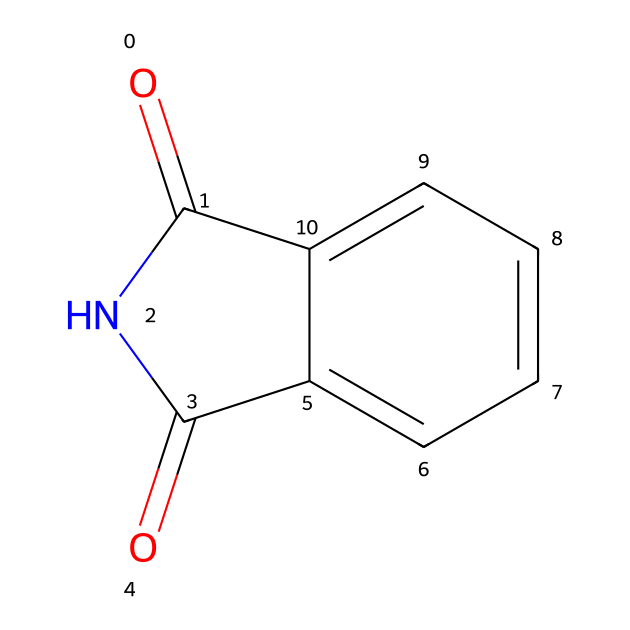What is the molecular formula of phthalimide? By analyzing the structure provided, we identify the types and quantities of each atom in phthalimide. The chemical structure contains 8 carbon atoms, 5 hydrogen atoms, 2 nitrogen atoms, and 2 oxygen atoms. Constructing the molecular formula from this information gives us C8H5N2O2.
Answer: C8H5N2O2 How many rings are present in the structure of phthalimide? Observing the structure, we see that phthalimide contains one cyclic structure, indicated by the presence of a ring formed by the bonding between nitrogen and carbon atoms.
Answer: 1 What functional groups are present in phthalimide? The structure reveals that phthalimide contains an imide group, characterized by the nitrogen atoms bonded to carbonyl groups (C=O). The presence of two carbonyls adjacent to the nitrogen highlights this functional group's significance.
Answer: imide What is the hybridization of the nitrogen atom in phthalimide? Looking at the structure, we note that the nitrogen atoms are bonded to carbonyl groups and carbon atoms, sharing electron pairs. This bonding suggests a trigonal planar arrangement, leading us to conclude that the nitrogen atoms are sp2 hybridized.
Answer: sp2 What type of reaction may phthalimide undergo in pesticide synthesis? In the context of pesticide synthesis, phthalimide is likely to participate in a nucleophilic substitution reaction due to the presence of reactive sites (nitrogen and carbonyls). This type of reaction is crucial in forming new pesticide compounds by replacing certain functional groups.
Answer: nucleophilic substitution How many carbonyl groups are in the phthalimide structure? Upon closely examining the structure, we see two carbonyl groups (C=O) attached to the nitrogen atoms. This indicates the unique characteristic of imides, where nitrogen is bonded to carbonyl carbon atoms.
Answer: 2 